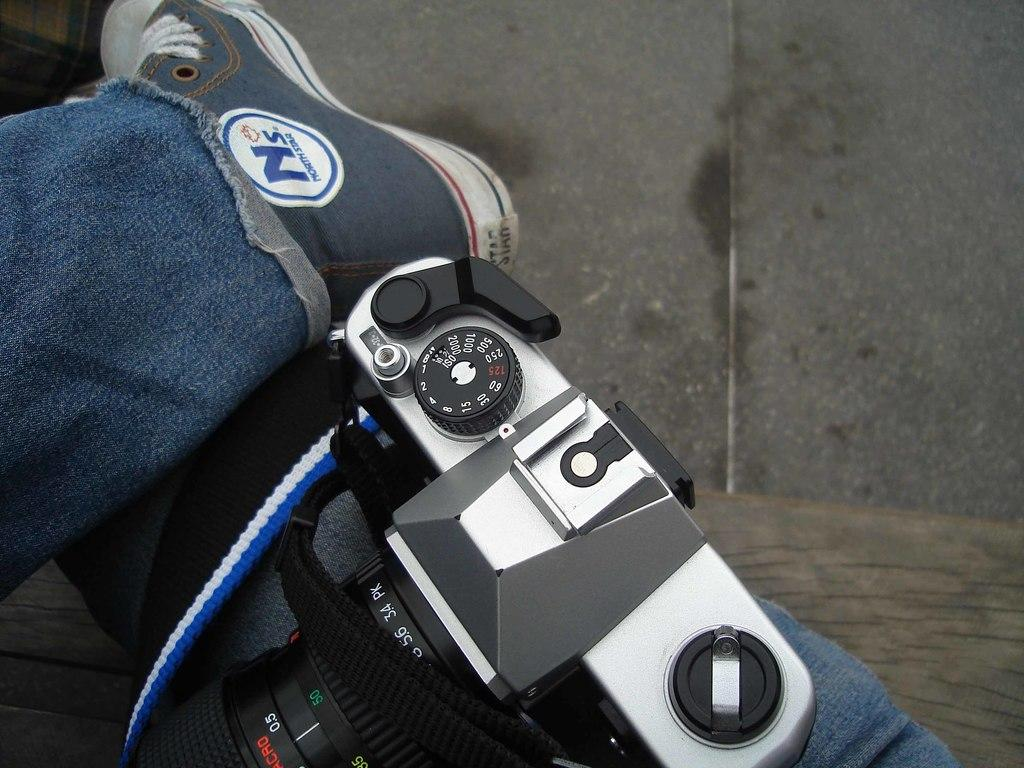What object is the main focus of the image? There is a camera in the image. Can you describe any part of a person in the image? A person's leg is visible in the image. What type of surface can be seen in the background of the image? There is a floor in the background of the image. What material is the surface at the bottom of the image made of? There is a wooden surface at the bottom of the image. How many cherries are on top of the camera in the image? There are no cherries present in the image, as it features a camera, a person's leg, a floor, and a wooden surface. 